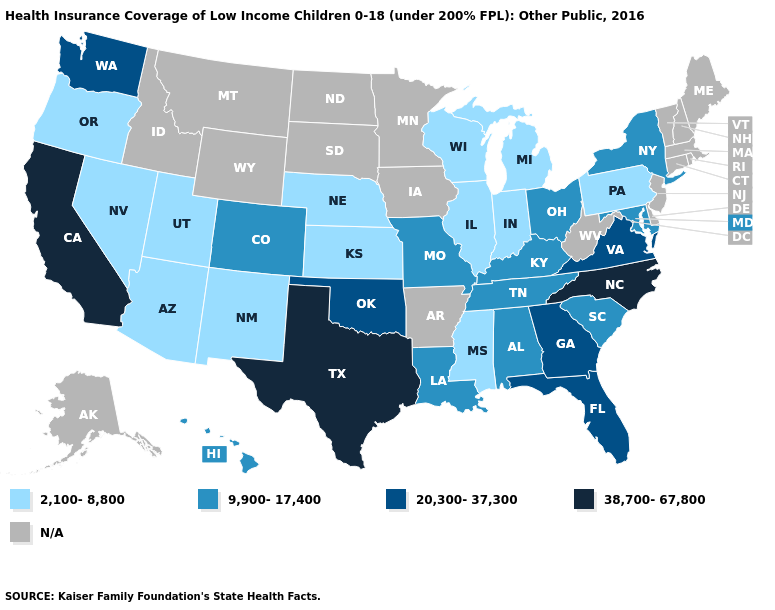What is the value of Maine?
Concise answer only. N/A. What is the highest value in states that border Delaware?
Be succinct. 9,900-17,400. What is the lowest value in states that border Michigan?
Write a very short answer. 2,100-8,800. What is the highest value in the West ?
Give a very brief answer. 38,700-67,800. What is the lowest value in the USA?
Quick response, please. 2,100-8,800. Does the map have missing data?
Concise answer only. Yes. Name the states that have a value in the range 20,300-37,300?
Answer briefly. Florida, Georgia, Oklahoma, Virginia, Washington. Name the states that have a value in the range N/A?
Write a very short answer. Alaska, Arkansas, Connecticut, Delaware, Idaho, Iowa, Maine, Massachusetts, Minnesota, Montana, New Hampshire, New Jersey, North Dakota, Rhode Island, South Dakota, Vermont, West Virginia, Wyoming. Does Missouri have the lowest value in the MidWest?
Quick response, please. No. Does the first symbol in the legend represent the smallest category?
Be succinct. Yes. What is the value of Maryland?
Answer briefly. 9,900-17,400. Does Nevada have the lowest value in the West?
Give a very brief answer. Yes. Does the map have missing data?
Quick response, please. Yes. Name the states that have a value in the range 9,900-17,400?
Quick response, please. Alabama, Colorado, Hawaii, Kentucky, Louisiana, Maryland, Missouri, New York, Ohio, South Carolina, Tennessee. What is the highest value in the USA?
Concise answer only. 38,700-67,800. 